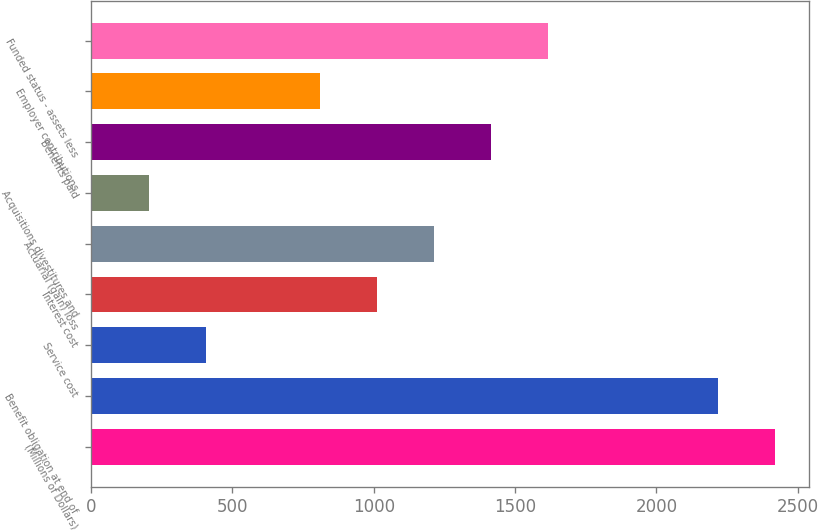Convert chart. <chart><loc_0><loc_0><loc_500><loc_500><bar_chart><fcel>(Millions of Dollars)<fcel>Benefit obligation at end of<fcel>Service cost<fcel>Interest cost<fcel>Actuarial (gain) loss<fcel>Acquisitions divestitures and<fcel>Benefits paid<fcel>Employer contributions<fcel>Funded status - assets less<nl><fcel>2419.36<fcel>2218.18<fcel>407.56<fcel>1011.1<fcel>1212.28<fcel>206.38<fcel>1413.46<fcel>809.92<fcel>1614.64<nl></chart> 